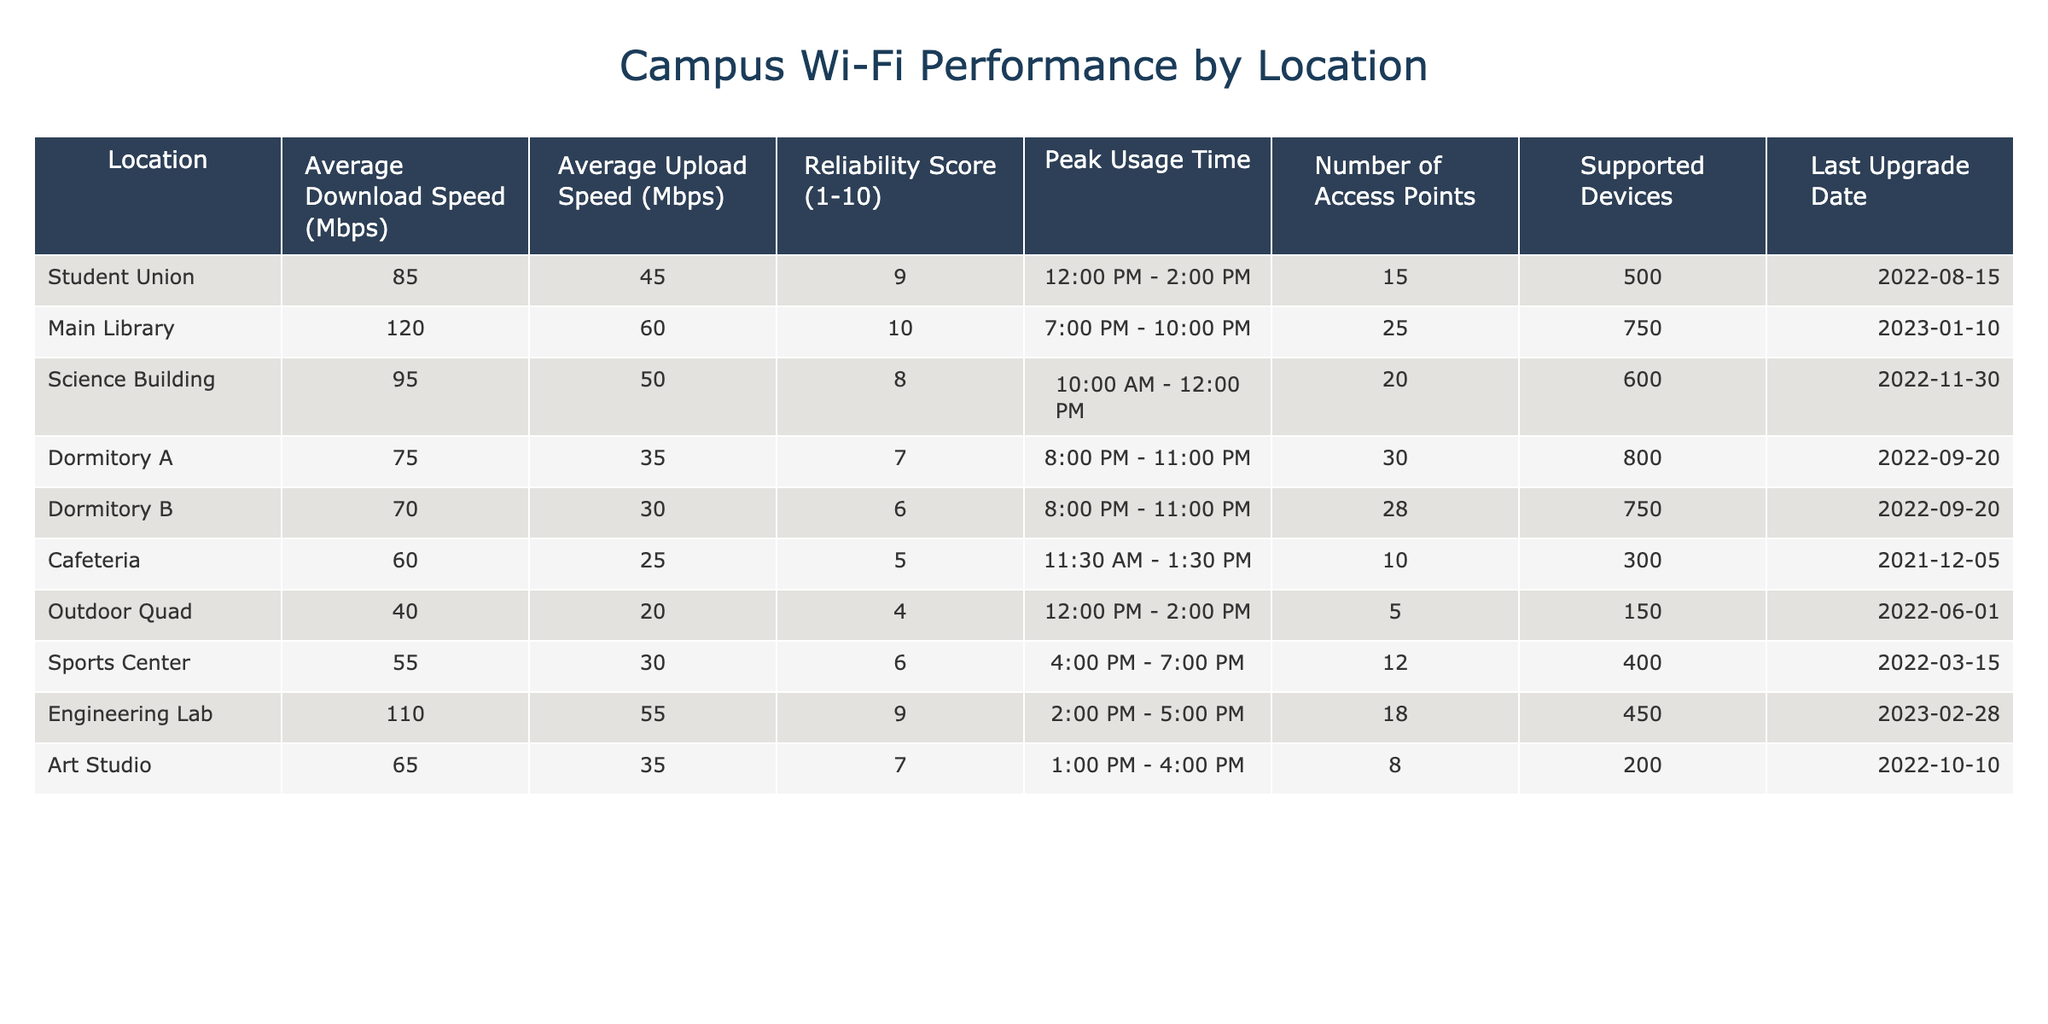What is the average download speed in the Main Library? Referring to the table, the Average Download Speed for the Main Library is listed as 120 Mbps.
Answer: 120 Mbps Which location has the highest reliability score? The table shows that the Main Library has the highest Reliability Score of 10.
Answer: Main Library How many access points are there in the Sports Center? According to the table, the Sports Center has 12 Access Points listed.
Answer: 12 What is the average upload speed across all locations? To calculate, sum the upload speeds: (45 + 60 + 50 + 35 + 30 + 25 + 20 + 30 + 55 + 35) =  400 Mbps. There are 10 locations: 400 / 10 = 40 Mbps average upload speed.
Answer: 40 Mbps Is the average download speed in the Cafeteria greater than that in Dormitory A? The Cafeteria has an average download speed of 60 Mbps, while Dormitory A has 75 Mbps. Since 60 is less than 75, the statement is false.
Answer: No Which location has more access points, the Science Building or the Engineering Lab? The Science Building has 20 Access Points, and the Engineering Lab has 18 Access Points. Therefore, the Science Building has more access points.
Answer: Science Building Do both Dormitory A and Dormitory B have the same reliability score? The table shows Dormitory A has a Reliability Score of 7 and Dormitory B has a score of 6. Since these scores are different, the statement is false.
Answer: No What is the peak usage time for the Outdoor Quad? The table indicates the peak usage time for the Outdoor Quad is 12:00 PM - 2:00 PM.
Answer: 12:00 PM - 2:00 PM If you were to combine the average download speeds of all dormitories, what would that be? The average download speeds of Dormitory A (75 Mbps) and Dormitory B (70 Mbps) combined is 75 + 70 = 145 Mbps.
Answer: 145 Mbps How many supported devices does the Main Library accommodate? The table indicates that the Main Library supports 750 devices.
Answer: 750 devices 